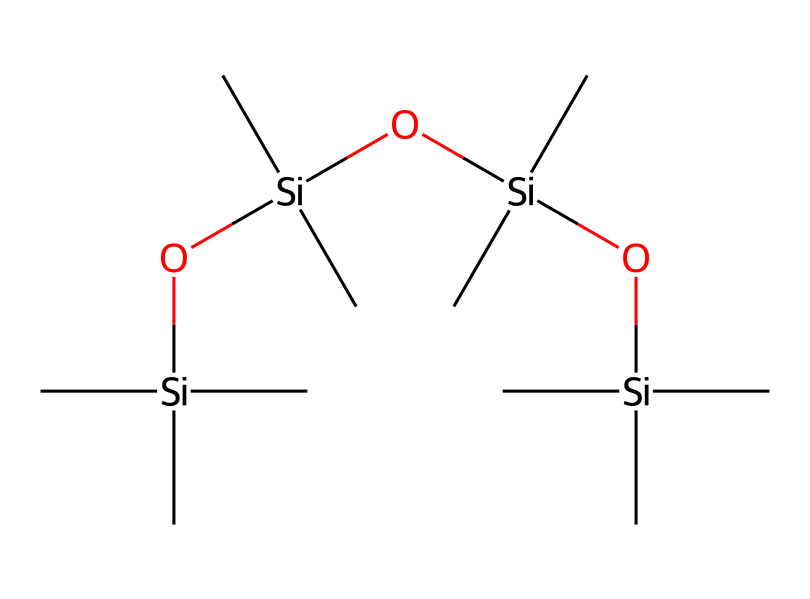What is the total number of silicon atoms in the compound? The SMILES representation shows multiple occurrences of silicon (Si) atoms. By analyzing the structure, we count a total of 5 silicon atoms linked through oxygen (O) and carbon (C) components.
Answer: 5 How many carbon atoms are present in the molecule? The SMILES representation highlights several carbon (C) atoms surrounding the silicon framework. Upon counting the carbon atoms represented in the structure, we find a total of 12 carbon atoms.
Answer: 12 What type of chemical bonds mainly connect the silicon atoms? In organosilicon compounds, silicon atoms are primarily connected by siloxane (Si-O) bonds. In this structure, these bonds allow connectivity between the silicons and the oxygens.
Answer: siloxane How many hydroxyl (OH) groups are present in this chemical? By examining the SMILES, we note that each silicon atom is bonded to hydroxyl (OH) functions, and upon inspection, we find there are 4 hydroxyl groups within the structure.
Answer: 4 What feature makes this compound suitable for use in smartphone screen protectors? The molecular structure indicates significant flexibility and durability due to the presence of organosilicon compounds, which provide strength and scratch resistance, essential for screen protectors.
Answer: flexibility and durability 